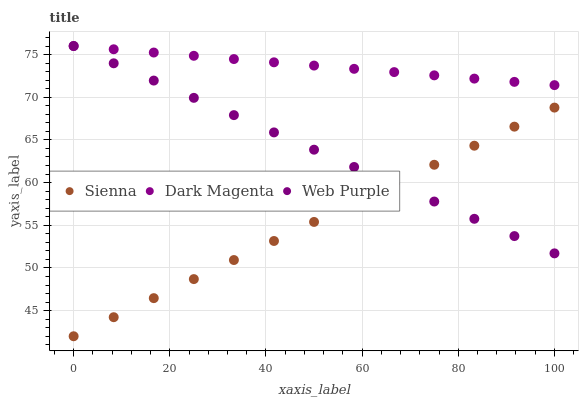Does Sienna have the minimum area under the curve?
Answer yes or no. Yes. Does Dark Magenta have the maximum area under the curve?
Answer yes or no. Yes. Does Web Purple have the minimum area under the curve?
Answer yes or no. No. Does Web Purple have the maximum area under the curve?
Answer yes or no. No. Is Sienna the smoothest?
Answer yes or no. Yes. Is Dark Magenta the roughest?
Answer yes or no. Yes. Is Web Purple the smoothest?
Answer yes or no. No. Is Web Purple the roughest?
Answer yes or no. No. Does Sienna have the lowest value?
Answer yes or no. Yes. Does Web Purple have the lowest value?
Answer yes or no. No. Does Dark Magenta have the highest value?
Answer yes or no. Yes. Is Sienna less than Dark Magenta?
Answer yes or no. Yes. Is Dark Magenta greater than Sienna?
Answer yes or no. Yes. Does Web Purple intersect Dark Magenta?
Answer yes or no. Yes. Is Web Purple less than Dark Magenta?
Answer yes or no. No. Is Web Purple greater than Dark Magenta?
Answer yes or no. No. Does Sienna intersect Dark Magenta?
Answer yes or no. No. 